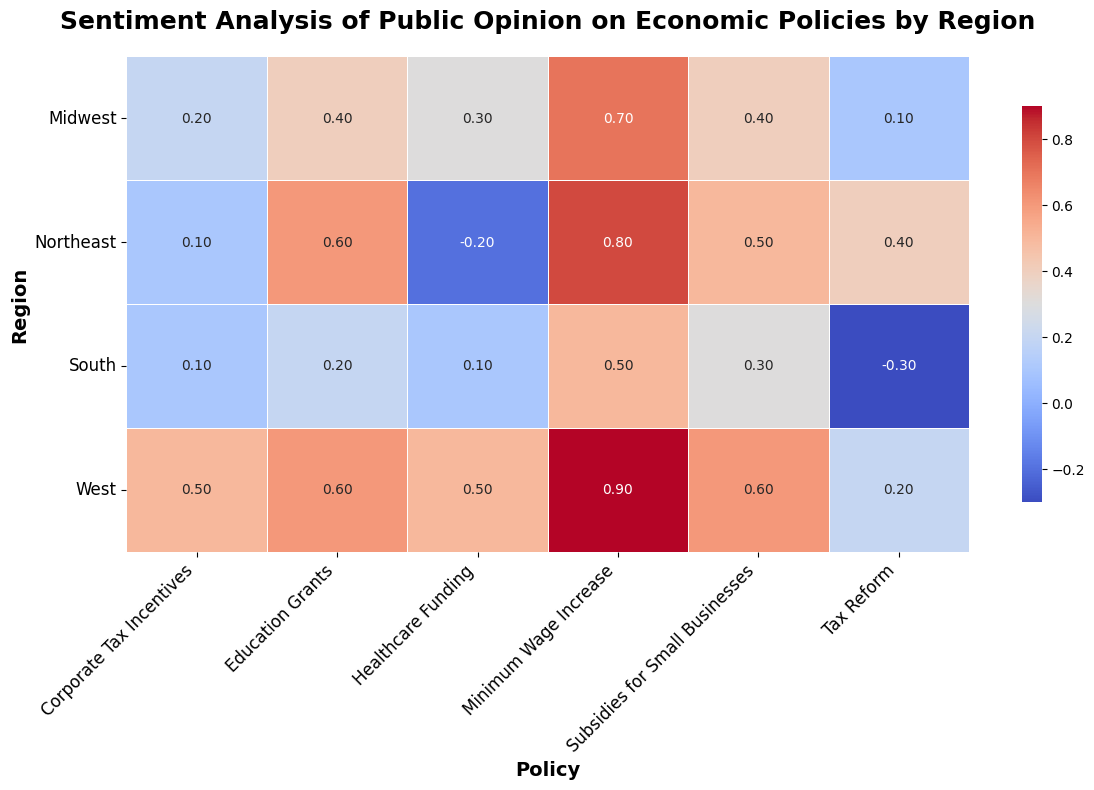What's the region with the highest positive sentiment towards the "Minimum Wage Increase" policy? To locate this, look at the "Minimum Wage Increase" column, then find the highest number. The West region has the highest sentiment score of 0.9.
Answer: West Which region has the most negative sentiment towards "Tax Reform"? Check the "Tax Reform" column and find the lowest number. The South region has the most negative sentiment score of -0.3.
Answer: South Compare the sentiment scores of the "Healthcare Funding" policy between the Midwest and Northeast regions. Which one has a higher sentiment score? Look at the "Healthcare Funding" row for both the Midwest (0.3) and Northeast (-0.2) regions. Compare these two values. The Midwest has a higher sentiment score of 0.3.
Answer: Midwest Which policy has uniform sentiment (either all positive or all negative) across all regions? Scan through each policy's column to see if all the sentiment scores are either positive or negative. "Corporate Tax Incentives" has all positive sentiments in all regions.
Answer: Corporate Tax Incentives What is the average sentiment score for the "Subsidies for Small Businesses" policy across all regions? Add up the sentiment scores for "Subsidies for Small Businesses" (0.5, 0.4, 0.3, 0.6), and then divide by the number of regions (4). (0.5 + 0.4 + 0.3 + 0.6) / 4 = 0.45
Answer: 0.45 For which policy is the difference in sentiment between the Northeast and South regions the largest? Calculate the absolute difference in sentiment scores between the Northeast and South regions for each policy, then find the largest value. The "Education Grants" policy has the largest difference:
Answer: Education Grants Which region shows the greatest variation in sentiment across all policies? Calculate the range of sentiment scores (maximum - minimum) for each region. The West region shows the greatest variation, ranging from 0.2 to 0.9 (a range of 0.7).
Answer: West What's the overall sentiment trend towards "Minimum Wage Increase" when moving from the South to the Northeast? Compare sentiment scores as you move from South (0.5) to Midwest (0.7) to Northeast (0.8). The sentiment scores increase.
Answer: Increasing What is the total sentiment score for "Tax Reform" policy when summing across all regions? Add up the sentiment scores for "Tax Reform" (0.4, 0.1, -0.3, 0.2). 0.4 + 0.1 - 0.3 + 0.2 = 0.4
Answer: 0.4 